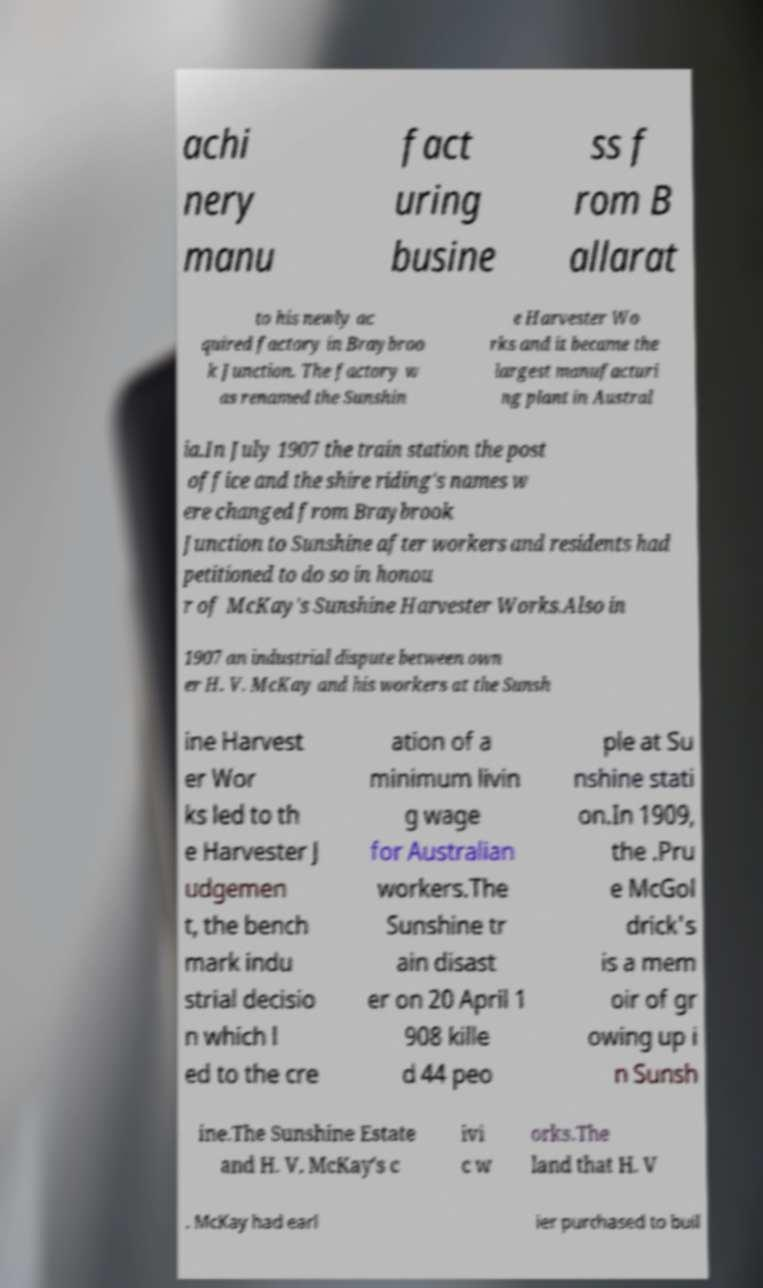For documentation purposes, I need the text within this image transcribed. Could you provide that? achi nery manu fact uring busine ss f rom B allarat to his newly ac quired factory in Braybroo k Junction. The factory w as renamed the Sunshin e Harvester Wo rks and it became the largest manufacturi ng plant in Austral ia.In July 1907 the train station the post office and the shire riding's names w ere changed from Braybrook Junction to Sunshine after workers and residents had petitioned to do so in honou r of McKay's Sunshine Harvester Works.Also in 1907 an industrial dispute between own er H. V. McKay and his workers at the Sunsh ine Harvest er Wor ks led to th e Harvester J udgemen t, the bench mark indu strial decisio n which l ed to the cre ation of a minimum livin g wage for Australian workers.The Sunshine tr ain disast er on 20 April 1 908 kille d 44 peo ple at Su nshine stati on.In 1909, the .Pru e McGol drick's is a mem oir of gr owing up i n Sunsh ine.The Sunshine Estate and H. V. McKay's c ivi c w orks.The land that H. V . McKay had earl ier purchased to buil 